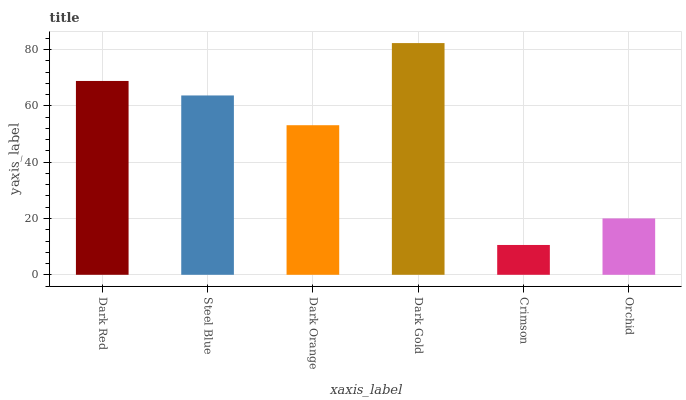Is Crimson the minimum?
Answer yes or no. Yes. Is Dark Gold the maximum?
Answer yes or no. Yes. Is Steel Blue the minimum?
Answer yes or no. No. Is Steel Blue the maximum?
Answer yes or no. No. Is Dark Red greater than Steel Blue?
Answer yes or no. Yes. Is Steel Blue less than Dark Red?
Answer yes or no. Yes. Is Steel Blue greater than Dark Red?
Answer yes or no. No. Is Dark Red less than Steel Blue?
Answer yes or no. No. Is Steel Blue the high median?
Answer yes or no. Yes. Is Dark Orange the low median?
Answer yes or no. Yes. Is Crimson the high median?
Answer yes or no. No. Is Crimson the low median?
Answer yes or no. No. 